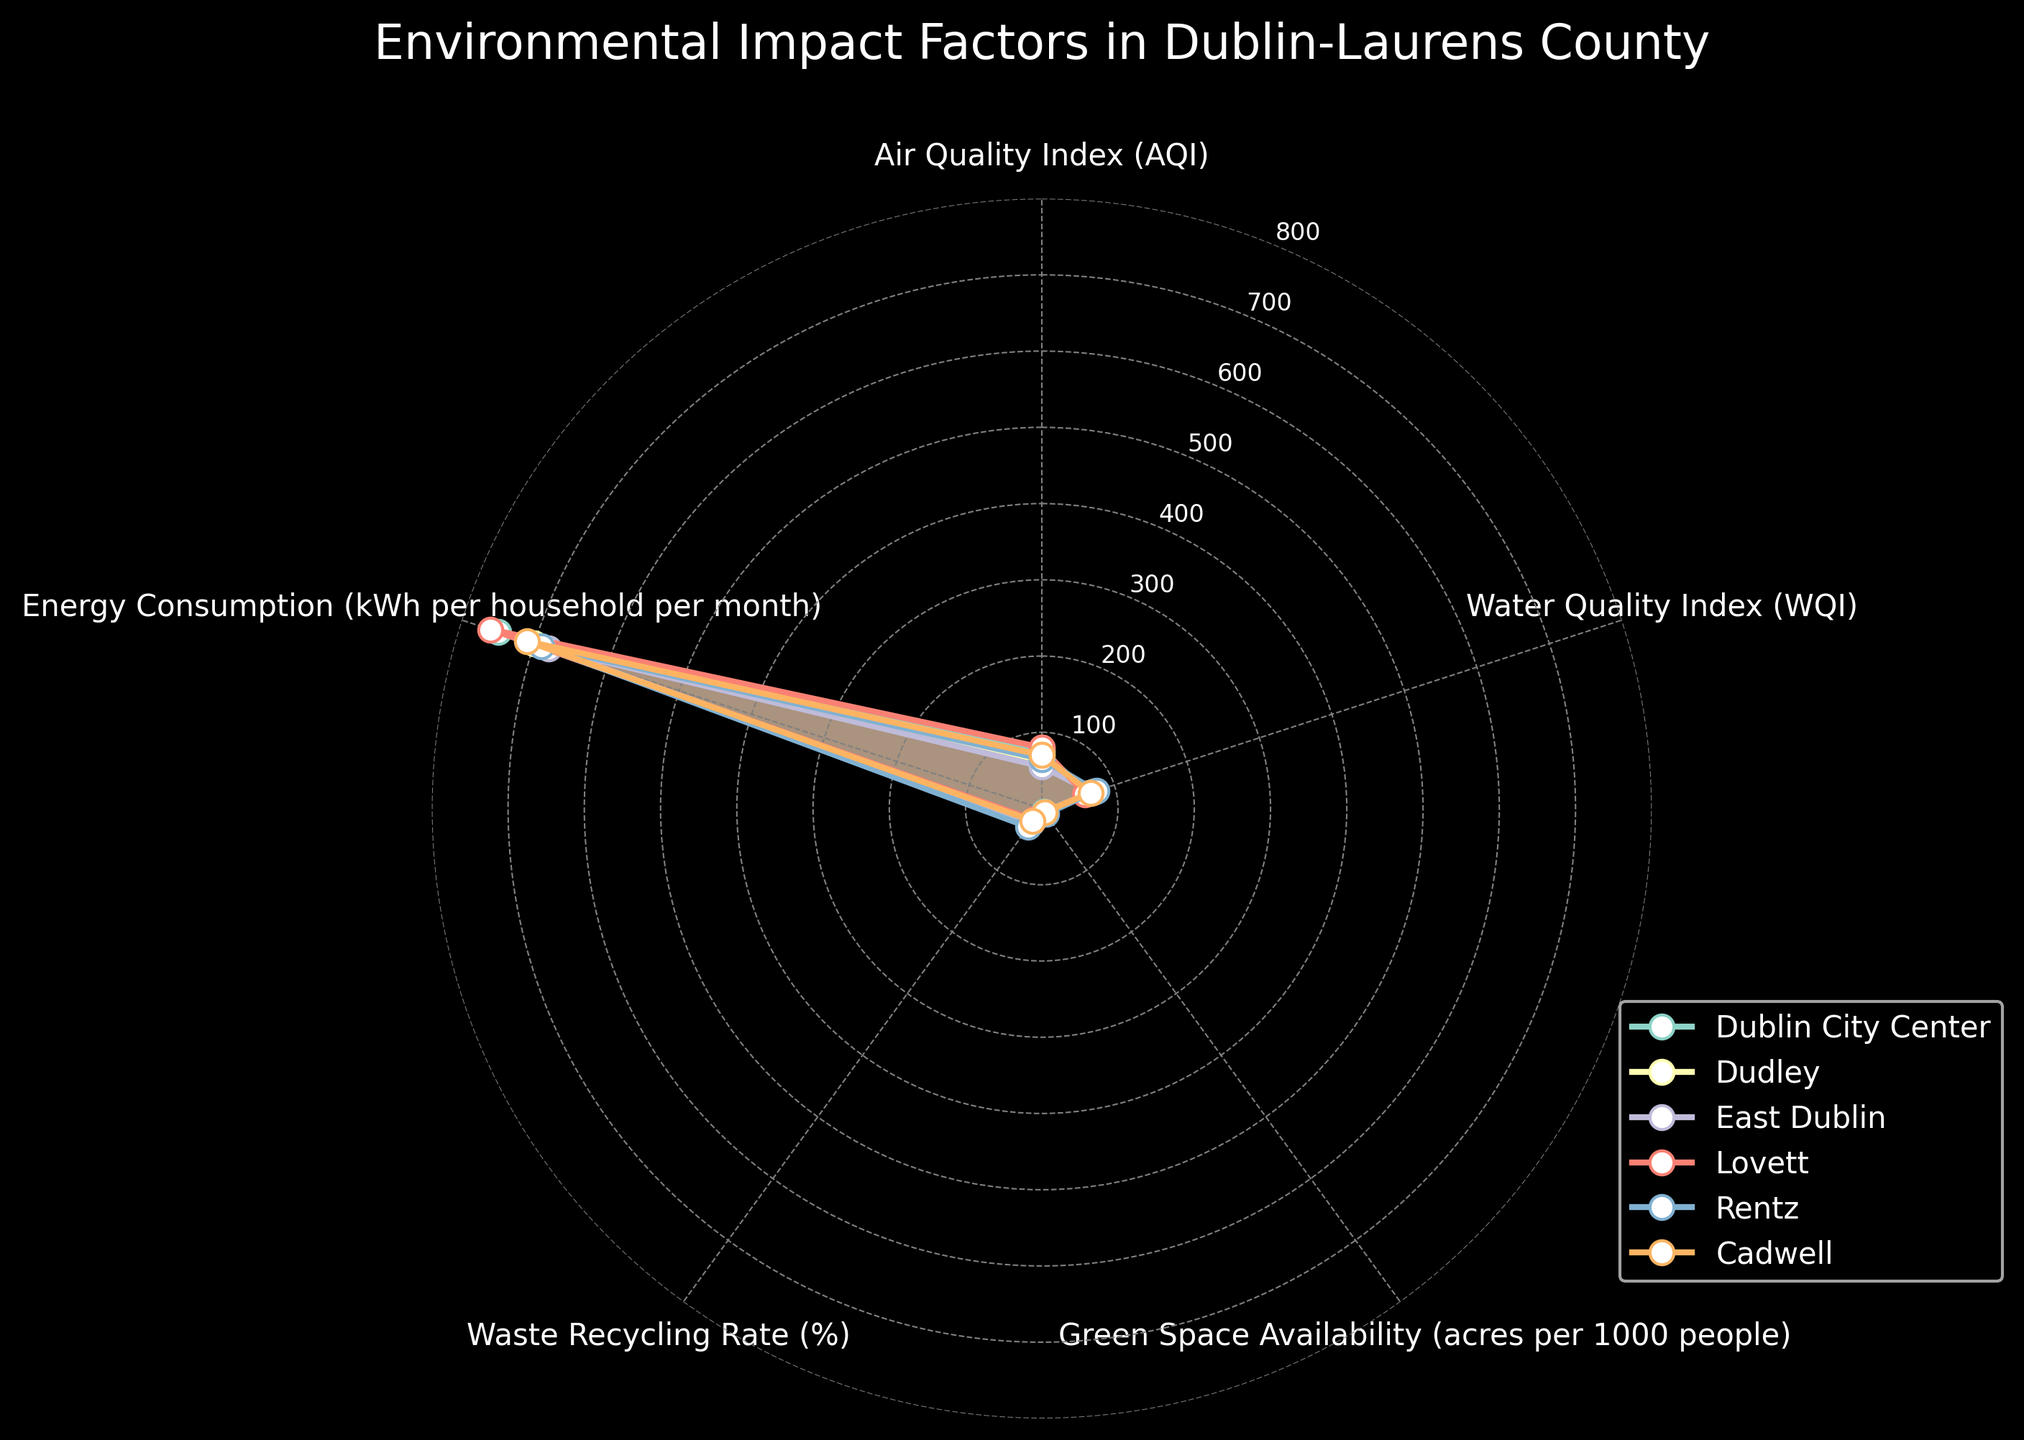What is the title of the radar chart? The title is located at the top center of the chart and provides an overview of the radar chart's content.
Answer: Environmental Impact Factors in Dublin-Laurens County Which location has the highest Air Quality Index (AQI)? By examining the air quality section of the radar chart, you can identify the location with the highest value on the Air Quality Index.
Answer: Lovett What is the minimum value of Energy Consumption across all locations? Look at the energy consumption patterns for all the locations in the radar chart and identify the smallest value.
Answer: 680 kWh Which location has the largest green space availability? Check the section for green space on the radar chart and find the location with the highest value.
Answer: Rentz Compare the Waste Recycling Rates between Dublin City Center and Cadwell. Which has a higher rate? By comparing the values in the Waste Recycling Rate section for Dublin City Center (20%) and Cadwell (20%), you can determine if one is higher or if they are equal.
Answer: Both have the same rate Which location has the lowest Water Quality Index (WQI)? By looking at the water quality section of the radar chart, identify the location with the lowest point.
Answer: Lovett List the locations that have an Energy Consumption pattern greater than 700 kWh per household per month. Check the energy consumption patterns on the radar chart and list the locations where the values exceed 700 kWh.
Answer: Dublin City Center, Lovett, Cadwell 